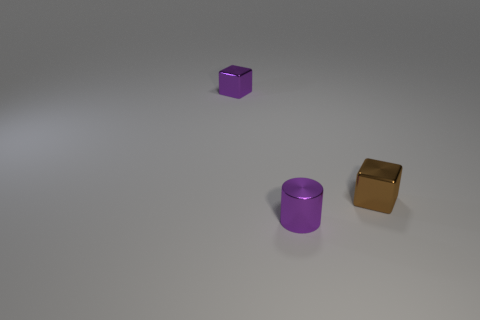How many objects are in this image, and can you describe their shapes? There are three objects in this image: a small purple cube, a purple cylinder, and a shiny, gold-colored cylinder. Each object has a distinct geometric shape. 